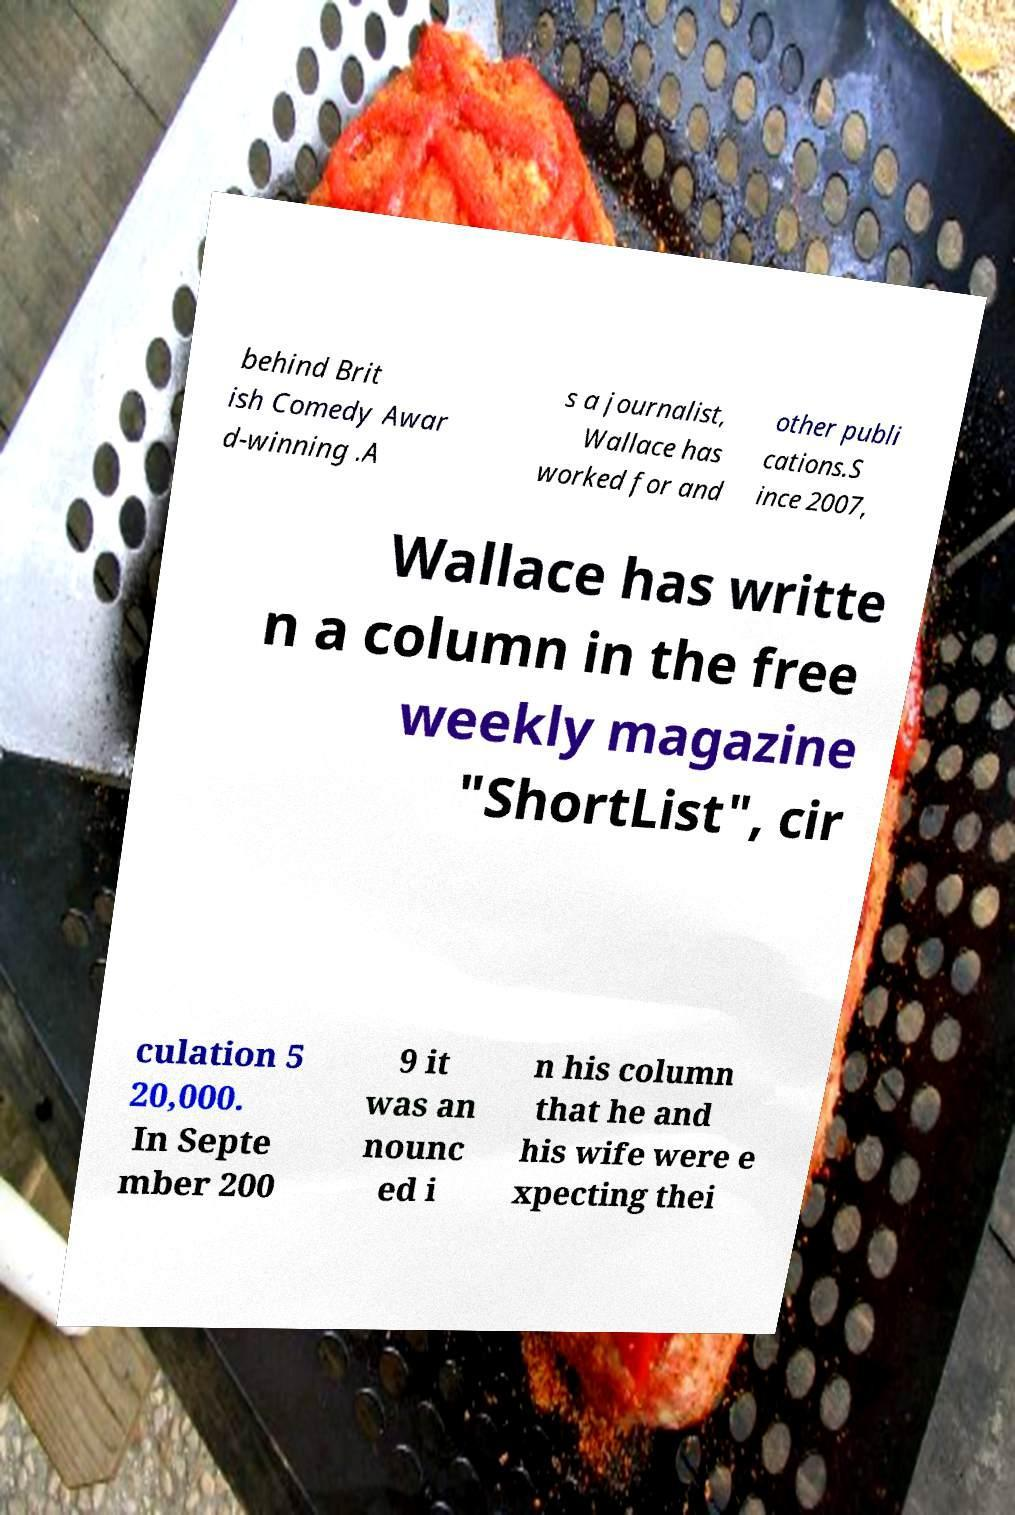I need the written content from this picture converted into text. Can you do that? behind Brit ish Comedy Awar d-winning .A s a journalist, Wallace has worked for and other publi cations.S ince 2007, Wallace has writte n a column in the free weekly magazine "ShortList", cir culation 5 20,000. In Septe mber 200 9 it was an nounc ed i n his column that he and his wife were e xpecting thei 